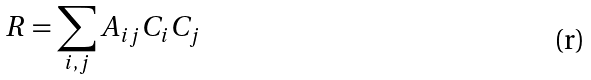Convert formula to latex. <formula><loc_0><loc_0><loc_500><loc_500>R = \sum _ { i , j } A _ { i j } C _ { i } C _ { j }</formula> 